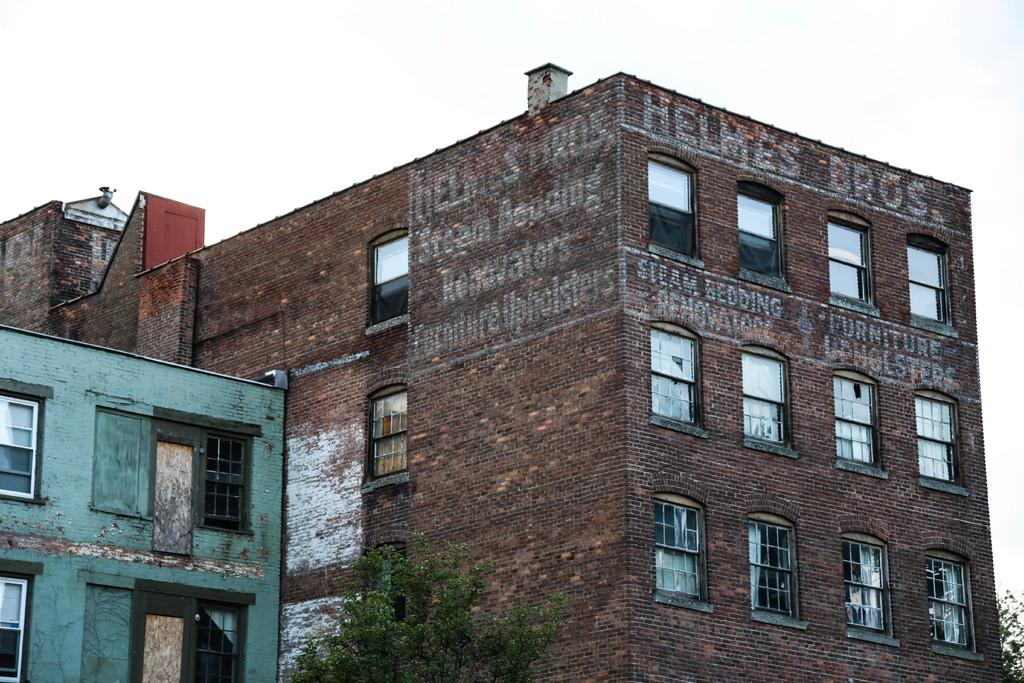What is the main subject in the center of the image? There are buildings in the center of the image. What can be seen in the front of the image? There is a tree in the front of the image. Are there any words or letters visible in the image? Yes, there is text written on the wall of a building. How would you describe the sky in the image? The sky is cloudy. What type of teeth can be seen on the judge in the image? There is no judge or teeth present in the image. How comfortable is the tree in the image? The image does not provide information about the comfort of the tree, as it is an inanimate object. 